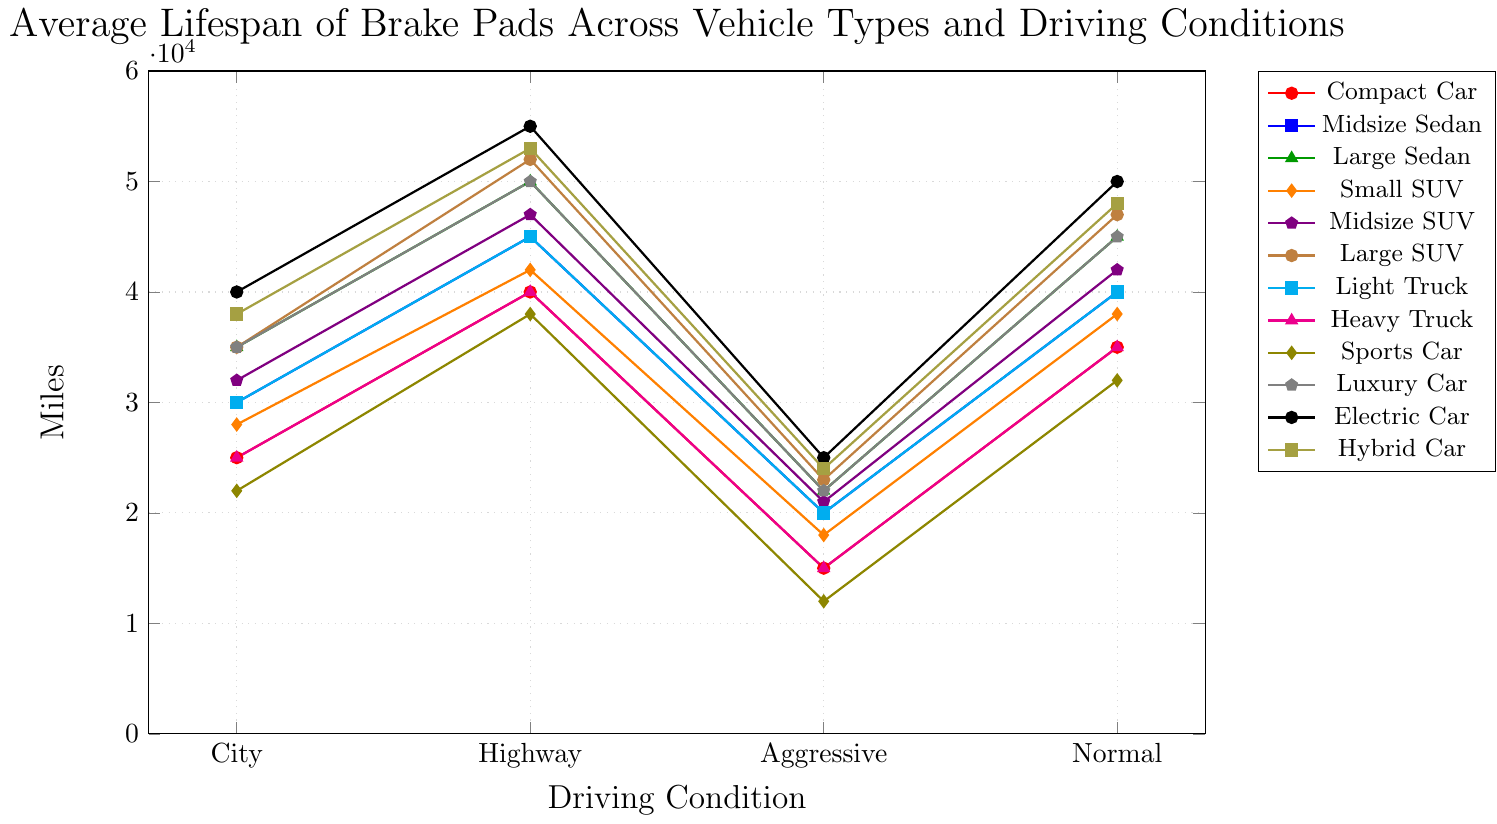Which vehicle type has the longest brake pad lifespan in highway driving conditions? Look at the data for highway driving conditions, the highest value is 55000 miles, corresponding to Electric Car.
Answer: Electric Car What is the difference in brake pad lifespan between Electric Car and Luxury Car under normal driving conditions? Compare Electric Car and Luxury Car for normal driving conditions. Electric Car is at 50000 miles and Luxury Car is at 45000 miles. The difference is 50000 - 45000 = 5000 miles.
Answer: 5000 miles Which driving condition results in the shortest brake pad lifespan for Sports Cars? Compare the brake pad lifespan for Sports Car across all driving conditions. The values are 22000 (city), 38000 (highway), 12000 (aggressive), and 32000 (normal). The smallest value is 12000 miles under aggressive driving.
Answer: Aggressive Driving Rank the vehicle types based on brake pad lifespan under city driving conditions from longest to shortest. Arrange the values under city driving conditions in descending order: Electric Car (40000), Hybrid Car (38000), Large Sedan (35000), Large SUV (35000), Luxury Car (35000), Midsize SUV (32000), Midsize Sedan (30000), Light Truck (30000), Small SUV (28000), Compact Car (25000), Heavy Truck (25000), Sports Car (22000).
Answer: Electric Car, Hybrid Car, Large Sedan, Large SUV, Luxury Car, Midsize SUV, Midsize Sedan, Light Truck, Small SUV, Compact Car, Heavy Truck, Sports Car How much longer do brake pads last on average for Normal Driving compared to Aggressive Driving for Midsize SUV? Compare the lifespan values for Midsize SUV under normal and aggressive driving conditions: 42000 (normal) and 21000 (aggressive). The difference is 42000 - 21000 = 21000 miles.
Answer: 21000 miles For which vehicle type is the gap between highway and city driving lifespan the largest? Calculate the difference between highway and city driving lifespan for each vehicle type. The largest difference is for Electric Car with 55000 (highway) - 40000 (city) = 15000 miles.
Answer: Electric Car What is the average brake pad lifespan for Light Truck across all driving conditions? Sum the lifespan values for Light Truck under all driving conditions and divide by the number of conditions: (30000 + 45000 + 20000 + 40000) / 4 = 135000 / 4 = 33750 miles.
Answer: 33750 miles Which vehicle type has a consistent brake pad lifespan across all driving conditions, and what is the approximate value? Identify the vehicle type with the least variation in lifespan across all conditions. Large Sedan has values 35000, 50000, 22000, 45000 with an approximate average value of about 38000 miles.
Answer: Large Sedan, about 38000 miles By how much does the brake pad lifespan for Midsize Sedan under highway driving exceed that of Compact Car under the same condition? Compare the highway driving lifespan values for Midsize Sedan and Compact Car: 45000 for Midsize Sedan and 40000 for Compact Car. The difference is 45000 - 40000 = 5000 miles.
Answer: 5000 miles Which vehicle type shows the highest variability in brake pad lifespan across different driving conditions? Calculate the range for each vehicle type, defining range as maximum lifespan minus minimum lifespan. Electric Car has the highest variability with values 55000 (highest) - 25000 (lowest) = 30000 miles.
Answer: Electric Car 